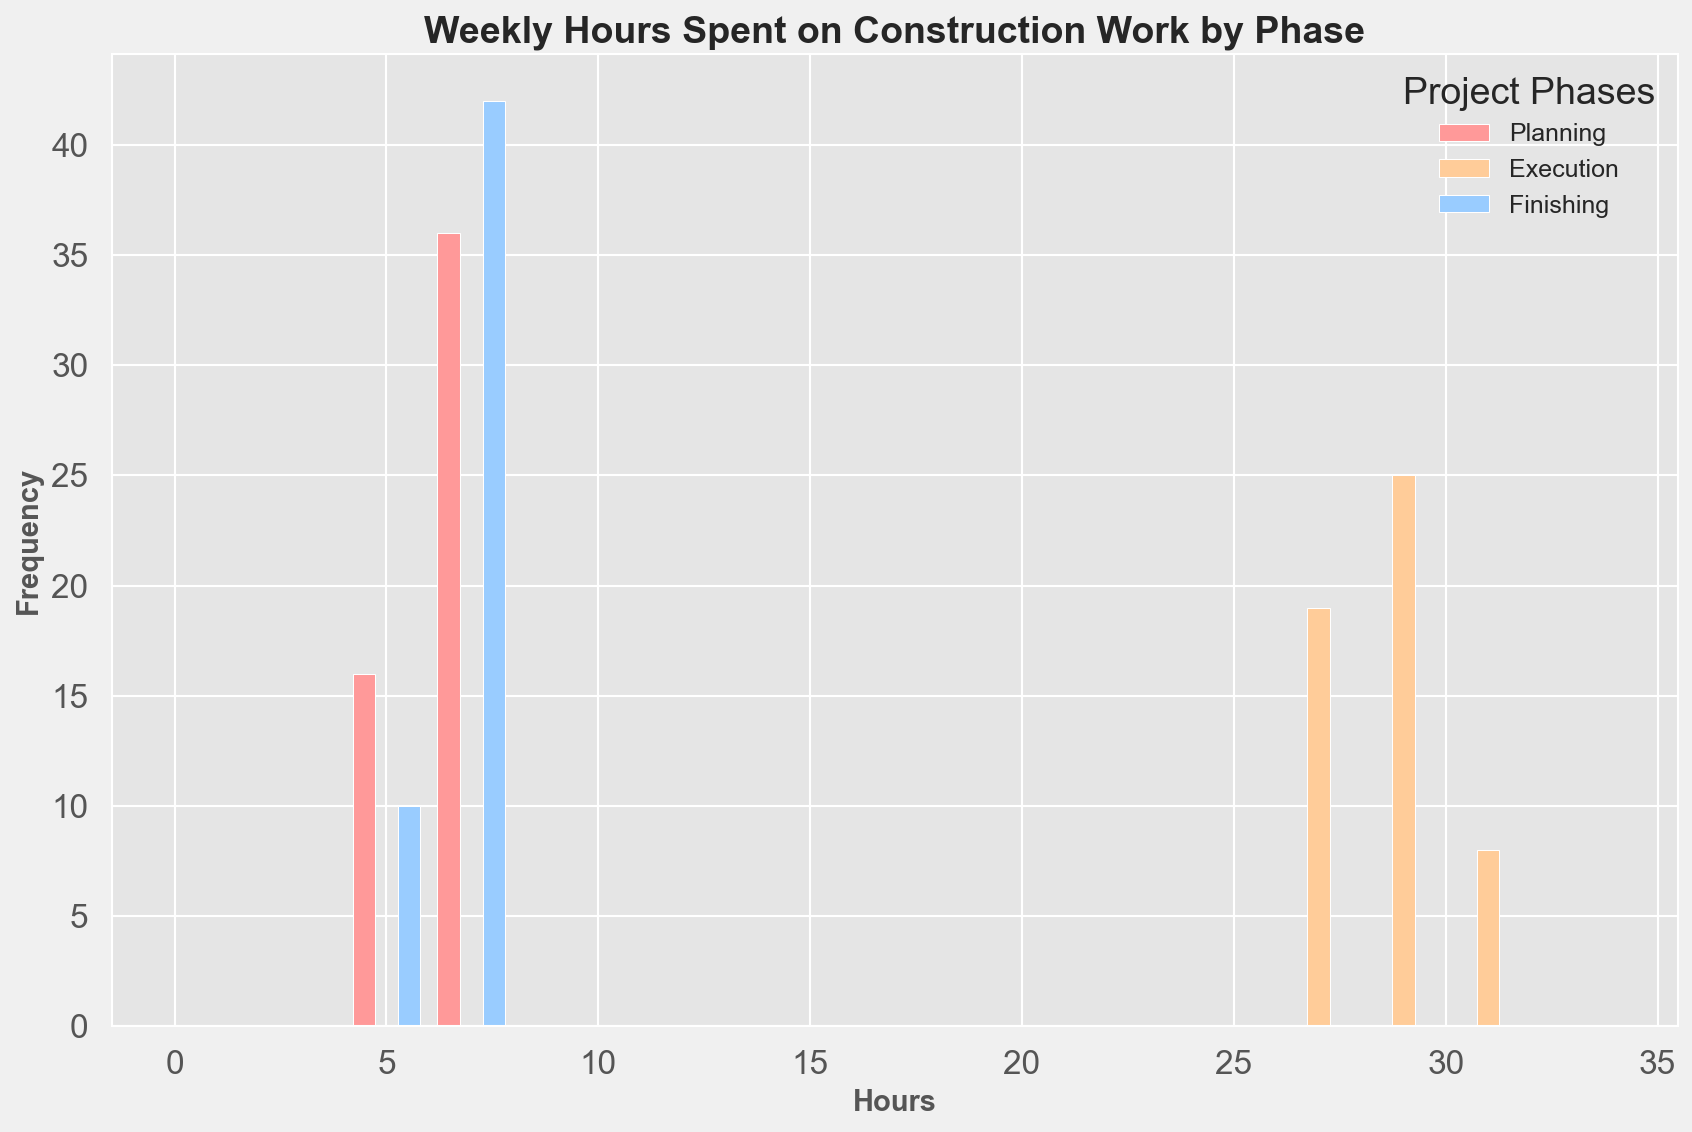Which project phase has the highest frequency of weekly hours spent between 28 and 30? To determine this, look at the bins that cover 28 to 30 hours and identify the tallest bar within this range, and see which project phase it corresponds to.
Answer: Execution How many total bins are there in the histogram? Identify the number of unique bins shown on the x-axis by counting them from the leftmost to rightmost bar.
Answer: 18 Which color represents the planning phase in the histogram? Identify the label associated with the planning phase by matching it with its color in the legend.
Answer: Red Is the frequency of planning hours higher than execution hours in any bin? Look at each bin and compare the height of the bar representing planning hours (red) with that of execution hours (orange). No bar for planning hours (red) exceeds the corresponding bar for execution hours (orange).
Answer: No Between 4 to 6 hours, which phase has the highest frequency? Focus on the bars from the 4 to 6 hours range and identify the highest bar among them and see which project phase it corresponds to.
Answer: Planning What is the most frequent number of hours spent on finishing projects weekly? Look for the bin with the tallest bar that corresponds to the blue color representing the finishing phase.
Answer: 6 Which project phase shows the largest variation in weekly hours? Observe the spread and frequency distribution of each phase throughout the histogram. The phase with the widest spread and varied bar heights indicates the largest variation.
Answer: Execution Are there more weeks with 26 hours in execution or planning? Compare the height of the bars representing 26 hours for both execution (orange) and planning (red). The taller bar corresponds to more weeks for that phase.
Answer: Planning 